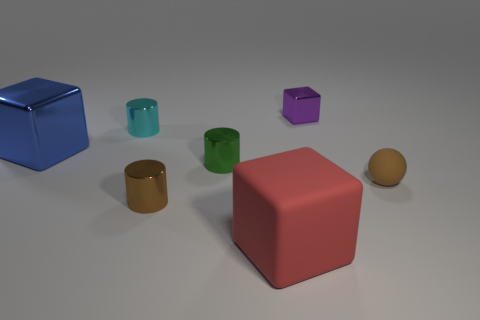What is the shape of the big thing behind the brown thing on the left side of the tiny ball?
Your response must be concise. Cube. What number of brown things are metal spheres or cylinders?
Provide a short and direct response. 1. There is a tiny cylinder behind the large blue thing in front of the purple metal object; are there any blue metallic objects to the right of it?
Your answer should be compact. No. What shape is the metallic thing that is the same color as the small matte sphere?
Offer a very short reply. Cylinder. Is there any other thing that has the same material as the red object?
Make the answer very short. Yes. What number of big objects are purple metallic cubes or purple metal cylinders?
Provide a short and direct response. 0. There is a tiny brown object that is to the right of the tiny brown shiny cylinder; is its shape the same as the tiny purple object?
Provide a succinct answer. No. Are there fewer small brown spheres than large brown objects?
Provide a succinct answer. No. Are there any other things that are the same color as the small sphere?
Provide a succinct answer. Yes. There is a large object behind the red rubber thing; what shape is it?
Provide a succinct answer. Cube. 